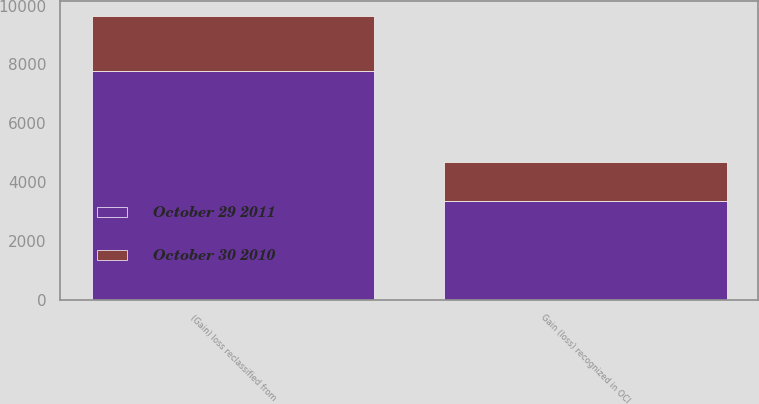Convert chart. <chart><loc_0><loc_0><loc_500><loc_500><stacked_bar_chart><ecel><fcel>Gain (loss) recognized in OCI<fcel>(Gain) loss reclassified from<nl><fcel>October 29 2011<fcel>3347<fcel>7793<nl><fcel>October 30 2010<fcel>1339<fcel>1863<nl></chart> 